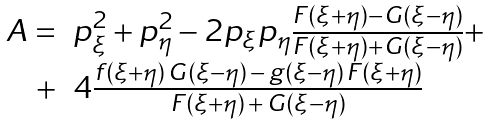Convert formula to latex. <formula><loc_0><loc_0><loc_500><loc_500>\begin{array} { r l } A = & p _ { \xi } ^ { 2 } + p _ { \eta } ^ { 2 } - 2 p _ { \xi } p _ { \eta } \frac { F ( \xi + \eta ) - G ( \xi - \eta ) } { F ( \xi + \eta ) + G ( \xi - \eta ) } + \\ + & 4 \frac { f ( \xi + \eta ) \, G ( \xi - \eta ) \, - \, g ( \xi - \eta ) \, F ( \xi + \eta ) } { F ( \xi + \eta ) \, + \, G ( \xi - \eta ) } \end{array}</formula> 